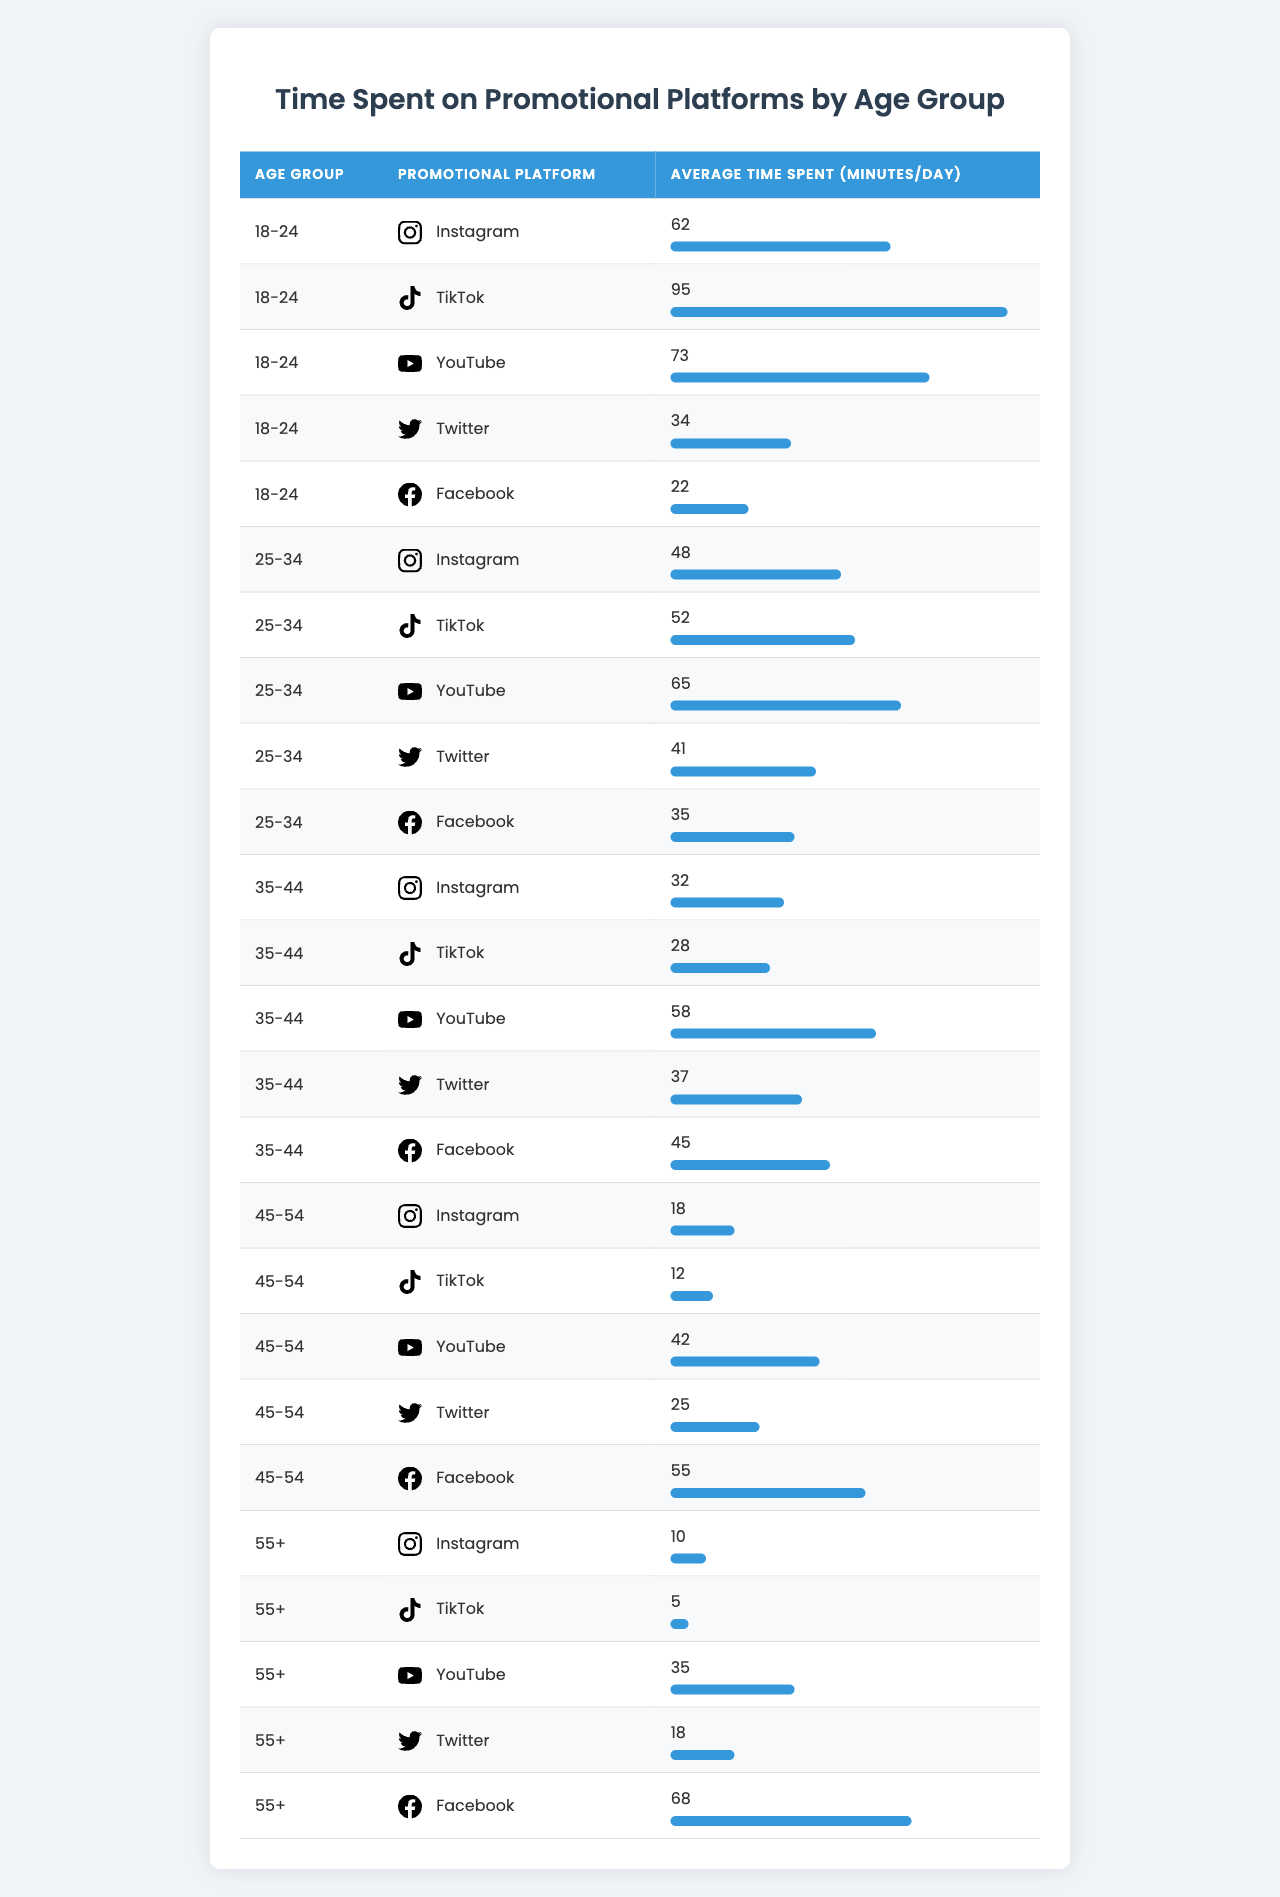What is the average time spent on Instagram by the 18-24 age group? The average time spent on Instagram for the 18-24 age group is listed as 62 minutes/day in the table.
Answer: 62 minutes Which age group spends the most time on TikTok? The 18-24 age group spends the most time on TikTok, with an average of 95 minutes/day, which is higher than other age groups listed.
Answer: 18-24 What is the total average time spent on YouTube across all age groups? To find the total average time spent on YouTube, we sum the values: (73 + 65 + 58 + 42 + 35) = 273. There are five age groups, so the average is 273/5 = 54.6 minutes.
Answer: 54.6 minutes Is the average time spent on Facebook by the 45-54 age group greater than the average for the 35-44 age group? For the 45-54 age group, the average time spent on Facebook is 55 minutes, while for the 35-44 age group, it is 45 minutes. Since 55 is greater than 45, the statement is true.
Answer: Yes What is the difference in average time spent on Twitter between the 25-34 and 35-44 age groups? For the 25-34 age group, the average time spent on Twitter is 41 minutes, and for the 35-44 age group, it is 37 minutes. The difference is 41 - 37 = 4 minutes.
Answer: 4 minutes Which promotional platform has the highest average time spent by the 55+ age group? The table shows that the average time spent on Facebook by the 55+ age group is 68 minutes, which is higher than the other platforms for that age group (10, 5, 35, 18 minutes).
Answer: Facebook What is the average time spent on TikTok by the 25-34 and 35-44 age groups combined? The average time spent on TikTok for the 25-34 age group is 52 minutes, and for the 35-44 age group, it is 28 minutes. Adding these values gives a total of 80 minutes, and dividing by the two age groups gives an average of 80/2 = 40 minutes.
Answer: 40 minutes Are there any age groups that spend more than 50 minutes on YouTube? The 18-24 age group spends 73 minutes, the 25-34 age group spends 65 minutes, and the 35-44 age group spends 58 minutes, all of which are greater than 50 minutes, confirming that there are multiple age groups that exceed this amount.
Answer: Yes Which platform do the 45-54 age group spend the least time on? The 45-54 age group spends the least time on TikTok, with an average of 12 minutes/day, which is lower than the time spent on other platforms for that age group.
Answer: TikTok What is the median time spent on Instagram across all age groups? First, we list the average time spent for Instagram by age groups: 62, 48, 32, 18, 10. Arranging these in order gives: 10, 18, 32, 48, 62. The median is the middle value, which is 32 minutes.
Answer: 32 minutes Which age group has the lowest average time spent on promotional platforms overall? To find this, we calculate the average time for each age group by summing their times and dividing by the number of platforms (5): 18-24: (62+95+73+34+22)/5 = 57.2, 25-34: (48+52+65+41+35)/5 = 48.2, 35-44: (32+28+58+37+45)/5 = 40, 45-54: (18+12+42+25+55)/5 = 30.4, 55+: (10+5+35+18+68)/5 = 27.2. The lowest average is for the 55+ age group.
Answer: 55+ 